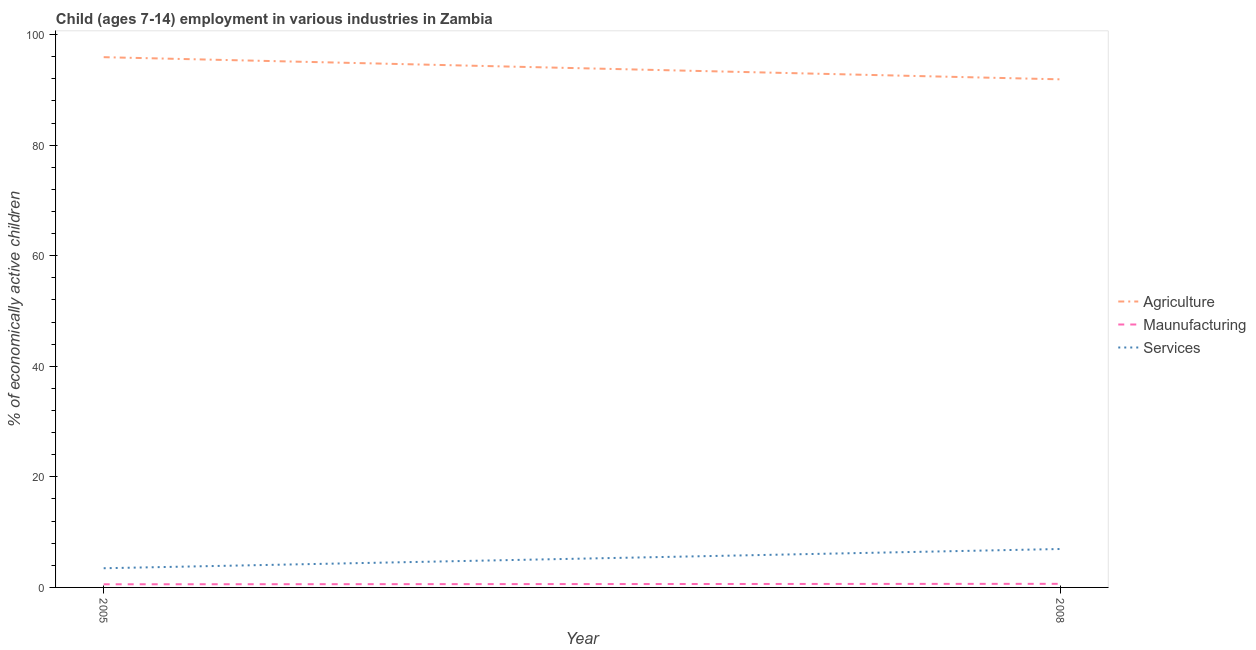How many different coloured lines are there?
Give a very brief answer. 3. Does the line corresponding to percentage of economically active children in agriculture intersect with the line corresponding to percentage of economically active children in manufacturing?
Your answer should be very brief. No. What is the percentage of economically active children in services in 2005?
Your answer should be very brief. 3.47. Across all years, what is the maximum percentage of economically active children in agriculture?
Make the answer very short. 95.91. Across all years, what is the minimum percentage of economically active children in manufacturing?
Offer a terse response. 0.57. What is the total percentage of economically active children in manufacturing in the graph?
Offer a terse response. 1.22. What is the difference between the percentage of economically active children in manufacturing in 2005 and that in 2008?
Keep it short and to the point. -0.08. What is the difference between the percentage of economically active children in manufacturing in 2008 and the percentage of economically active children in services in 2005?
Your answer should be compact. -2.82. What is the average percentage of economically active children in agriculture per year?
Make the answer very short. 93.91. What is the ratio of the percentage of economically active children in agriculture in 2005 to that in 2008?
Give a very brief answer. 1.04. Is the percentage of economically active children in services in 2005 less than that in 2008?
Provide a short and direct response. Yes. In how many years, is the percentage of economically active children in agriculture greater than the average percentage of economically active children in agriculture taken over all years?
Your answer should be compact. 1. Does the percentage of economically active children in manufacturing monotonically increase over the years?
Your answer should be compact. Yes. Is the percentage of economically active children in agriculture strictly less than the percentage of economically active children in manufacturing over the years?
Offer a very short reply. No. How many lines are there?
Your answer should be compact. 3. Does the graph contain any zero values?
Provide a short and direct response. No. Where does the legend appear in the graph?
Your answer should be compact. Center right. How are the legend labels stacked?
Your response must be concise. Vertical. What is the title of the graph?
Your answer should be compact. Child (ages 7-14) employment in various industries in Zambia. What is the label or title of the X-axis?
Provide a succinct answer. Year. What is the label or title of the Y-axis?
Your response must be concise. % of economically active children. What is the % of economically active children of Agriculture in 2005?
Make the answer very short. 95.91. What is the % of economically active children of Maunufacturing in 2005?
Keep it short and to the point. 0.57. What is the % of economically active children in Services in 2005?
Your answer should be very brief. 3.47. What is the % of economically active children of Agriculture in 2008?
Give a very brief answer. 91.9. What is the % of economically active children in Maunufacturing in 2008?
Offer a terse response. 0.65. What is the % of economically active children in Services in 2008?
Ensure brevity in your answer.  6.95. Across all years, what is the maximum % of economically active children of Agriculture?
Your response must be concise. 95.91. Across all years, what is the maximum % of economically active children of Maunufacturing?
Keep it short and to the point. 0.65. Across all years, what is the maximum % of economically active children in Services?
Ensure brevity in your answer.  6.95. Across all years, what is the minimum % of economically active children in Agriculture?
Make the answer very short. 91.9. Across all years, what is the minimum % of economically active children of Maunufacturing?
Your answer should be very brief. 0.57. Across all years, what is the minimum % of economically active children in Services?
Offer a very short reply. 3.47. What is the total % of economically active children in Agriculture in the graph?
Keep it short and to the point. 187.81. What is the total % of economically active children of Maunufacturing in the graph?
Your answer should be very brief. 1.22. What is the total % of economically active children of Services in the graph?
Provide a succinct answer. 10.42. What is the difference between the % of economically active children of Agriculture in 2005 and that in 2008?
Offer a very short reply. 4.01. What is the difference between the % of economically active children in Maunufacturing in 2005 and that in 2008?
Offer a very short reply. -0.08. What is the difference between the % of economically active children in Services in 2005 and that in 2008?
Your answer should be compact. -3.48. What is the difference between the % of economically active children in Agriculture in 2005 and the % of economically active children in Maunufacturing in 2008?
Ensure brevity in your answer.  95.26. What is the difference between the % of economically active children in Agriculture in 2005 and the % of economically active children in Services in 2008?
Make the answer very short. 88.96. What is the difference between the % of economically active children in Maunufacturing in 2005 and the % of economically active children in Services in 2008?
Make the answer very short. -6.38. What is the average % of economically active children of Agriculture per year?
Make the answer very short. 93.91. What is the average % of economically active children in Maunufacturing per year?
Your response must be concise. 0.61. What is the average % of economically active children of Services per year?
Your answer should be very brief. 5.21. In the year 2005, what is the difference between the % of economically active children of Agriculture and % of economically active children of Maunufacturing?
Make the answer very short. 95.34. In the year 2005, what is the difference between the % of economically active children in Agriculture and % of economically active children in Services?
Give a very brief answer. 92.44. In the year 2008, what is the difference between the % of economically active children in Agriculture and % of economically active children in Maunufacturing?
Keep it short and to the point. 91.25. In the year 2008, what is the difference between the % of economically active children of Agriculture and % of economically active children of Services?
Your response must be concise. 84.95. What is the ratio of the % of economically active children of Agriculture in 2005 to that in 2008?
Give a very brief answer. 1.04. What is the ratio of the % of economically active children of Maunufacturing in 2005 to that in 2008?
Your answer should be very brief. 0.88. What is the ratio of the % of economically active children of Services in 2005 to that in 2008?
Provide a short and direct response. 0.5. What is the difference between the highest and the second highest % of economically active children in Agriculture?
Keep it short and to the point. 4.01. What is the difference between the highest and the second highest % of economically active children in Maunufacturing?
Provide a short and direct response. 0.08. What is the difference between the highest and the second highest % of economically active children of Services?
Your response must be concise. 3.48. What is the difference between the highest and the lowest % of economically active children in Agriculture?
Provide a succinct answer. 4.01. What is the difference between the highest and the lowest % of economically active children of Services?
Provide a short and direct response. 3.48. 